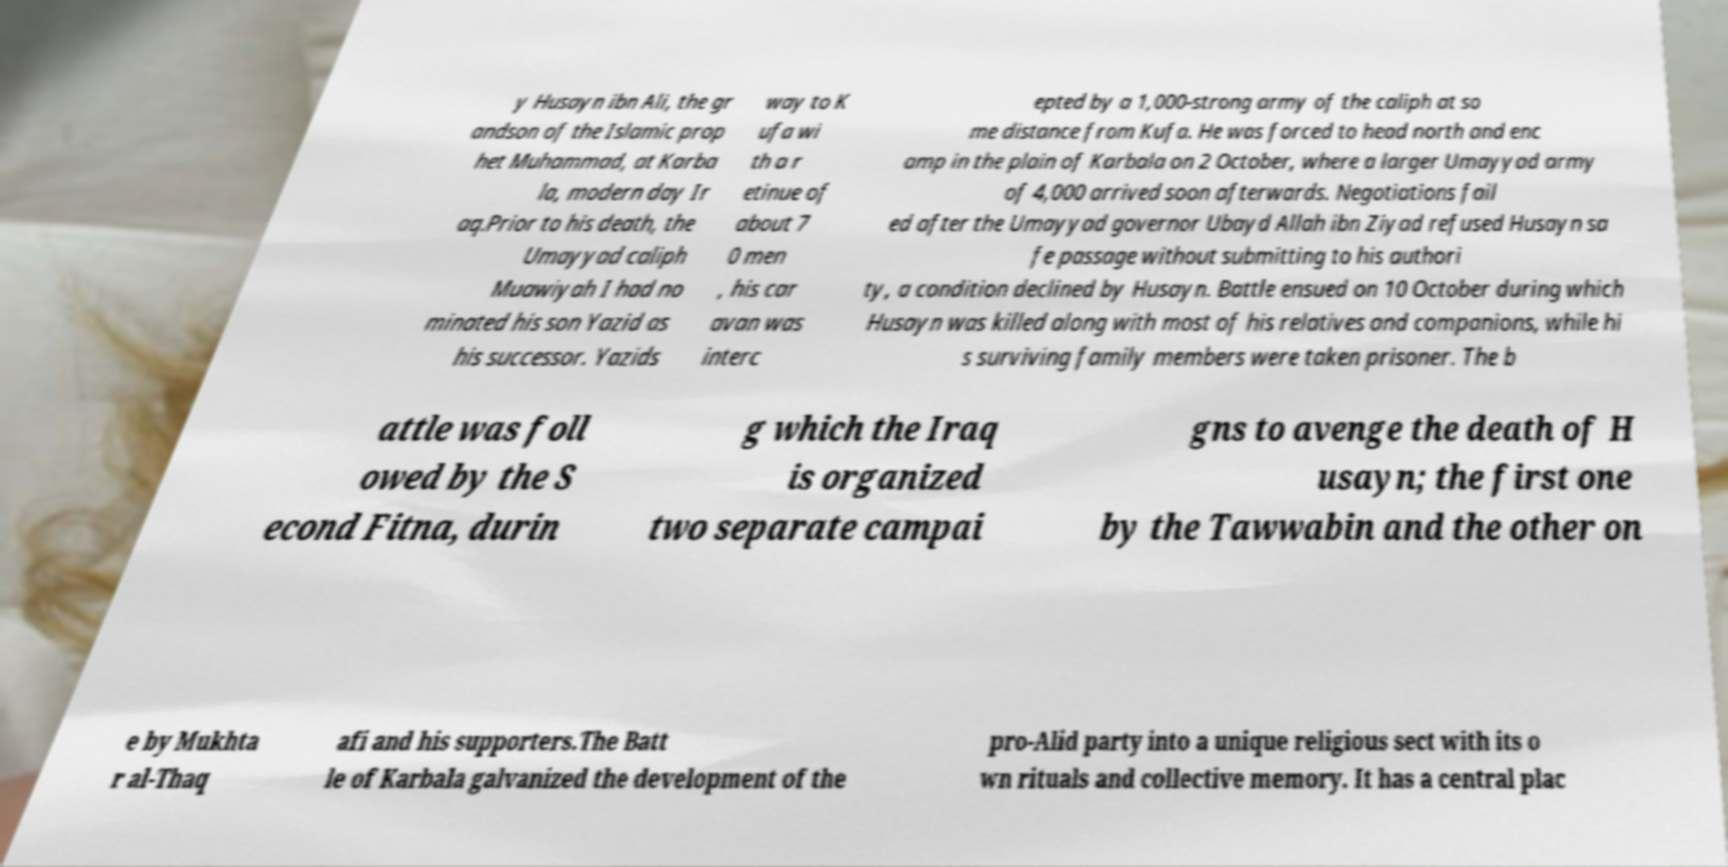What messages or text are displayed in this image? I need them in a readable, typed format. y Husayn ibn Ali, the gr andson of the Islamic prop het Muhammad, at Karba la, modern day Ir aq.Prior to his death, the Umayyad caliph Muawiyah I had no minated his son Yazid as his successor. Yazids way to K ufa wi th a r etinue of about 7 0 men , his car avan was interc epted by a 1,000-strong army of the caliph at so me distance from Kufa. He was forced to head north and enc amp in the plain of Karbala on 2 October, where a larger Umayyad army of 4,000 arrived soon afterwards. Negotiations fail ed after the Umayyad governor Ubayd Allah ibn Ziyad refused Husayn sa fe passage without submitting to his authori ty, a condition declined by Husayn. Battle ensued on 10 October during which Husayn was killed along with most of his relatives and companions, while hi s surviving family members were taken prisoner. The b attle was foll owed by the S econd Fitna, durin g which the Iraq is organized two separate campai gns to avenge the death of H usayn; the first one by the Tawwabin and the other on e by Mukhta r al-Thaq afi and his supporters.The Batt le of Karbala galvanized the development of the pro-Alid party into a unique religious sect with its o wn rituals and collective memory. It has a central plac 